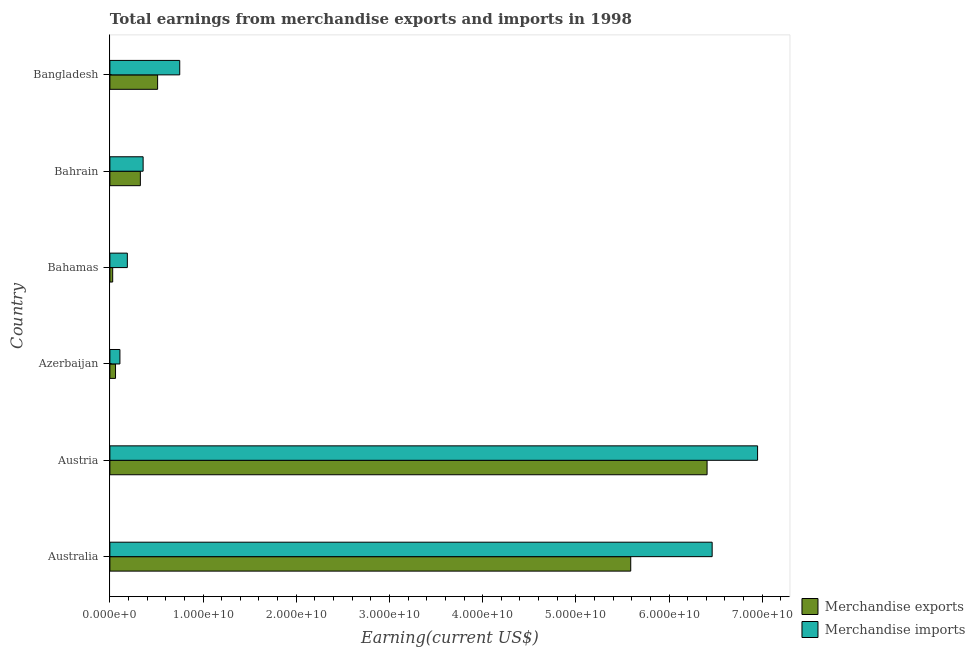How many different coloured bars are there?
Offer a terse response. 2. How many groups of bars are there?
Ensure brevity in your answer.  6. Are the number of bars per tick equal to the number of legend labels?
Make the answer very short. Yes. What is the label of the 6th group of bars from the top?
Your answer should be compact. Australia. In how many cases, is the number of bars for a given country not equal to the number of legend labels?
Provide a short and direct response. 0. What is the earnings from merchandise exports in Australia?
Make the answer very short. 5.59e+1. Across all countries, what is the maximum earnings from merchandise imports?
Provide a succinct answer. 6.95e+1. Across all countries, what is the minimum earnings from merchandise imports?
Provide a short and direct response. 1.08e+09. In which country was the earnings from merchandise exports minimum?
Give a very brief answer. Bahamas. What is the total earnings from merchandise exports in the graph?
Offer a terse response. 1.29e+11. What is the difference between the earnings from merchandise imports in Australia and that in Bangladesh?
Offer a terse response. 5.71e+1. What is the difference between the earnings from merchandise exports in Austria and the earnings from merchandise imports in Bahamas?
Your response must be concise. 6.22e+1. What is the average earnings from merchandise exports per country?
Give a very brief answer. 2.15e+1. What is the difference between the earnings from merchandise exports and earnings from merchandise imports in Austria?
Keep it short and to the point. -5.42e+09. What is the ratio of the earnings from merchandise exports in Australia to that in Azerbaijan?
Provide a succinct answer. 92.39. Is the earnings from merchandise imports in Australia less than that in Azerbaijan?
Your response must be concise. No. Is the difference between the earnings from merchandise imports in Australia and Bangladesh greater than the difference between the earnings from merchandise exports in Australia and Bangladesh?
Your answer should be compact. Yes. What is the difference between the highest and the second highest earnings from merchandise exports?
Provide a short and direct response. 8.19e+09. What is the difference between the highest and the lowest earnings from merchandise exports?
Give a very brief answer. 6.38e+1. In how many countries, is the earnings from merchandise imports greater than the average earnings from merchandise imports taken over all countries?
Your response must be concise. 2. Are all the bars in the graph horizontal?
Offer a very short reply. Yes. What is the difference between two consecutive major ticks on the X-axis?
Provide a short and direct response. 1.00e+1. Are the values on the major ticks of X-axis written in scientific E-notation?
Keep it short and to the point. Yes. Where does the legend appear in the graph?
Your response must be concise. Bottom right. How many legend labels are there?
Offer a terse response. 2. How are the legend labels stacked?
Keep it short and to the point. Vertical. What is the title of the graph?
Your answer should be compact. Total earnings from merchandise exports and imports in 1998. Does "Domestic Liabilities" appear as one of the legend labels in the graph?
Offer a very short reply. No. What is the label or title of the X-axis?
Give a very brief answer. Earning(current US$). What is the Earning(current US$) in Merchandise exports in Australia?
Ensure brevity in your answer.  5.59e+1. What is the Earning(current US$) in Merchandise imports in Australia?
Ensure brevity in your answer.  6.46e+1. What is the Earning(current US$) of Merchandise exports in Austria?
Give a very brief answer. 6.41e+1. What is the Earning(current US$) in Merchandise imports in Austria?
Offer a very short reply. 6.95e+1. What is the Earning(current US$) of Merchandise exports in Azerbaijan?
Your answer should be very brief. 6.05e+08. What is the Earning(current US$) of Merchandise imports in Azerbaijan?
Keep it short and to the point. 1.08e+09. What is the Earning(current US$) in Merchandise exports in Bahamas?
Offer a very short reply. 3.00e+08. What is the Earning(current US$) of Merchandise imports in Bahamas?
Keep it short and to the point. 1.87e+09. What is the Earning(current US$) of Merchandise exports in Bahrain?
Provide a short and direct response. 3.27e+09. What is the Earning(current US$) in Merchandise imports in Bahrain?
Make the answer very short. 3.57e+09. What is the Earning(current US$) of Merchandise exports in Bangladesh?
Your answer should be very brief. 5.12e+09. What is the Earning(current US$) in Merchandise imports in Bangladesh?
Keep it short and to the point. 7.50e+09. Across all countries, what is the maximum Earning(current US$) of Merchandise exports?
Give a very brief answer. 6.41e+1. Across all countries, what is the maximum Earning(current US$) in Merchandise imports?
Your answer should be compact. 6.95e+1. Across all countries, what is the minimum Earning(current US$) of Merchandise exports?
Your answer should be very brief. 3.00e+08. Across all countries, what is the minimum Earning(current US$) of Merchandise imports?
Offer a very short reply. 1.08e+09. What is the total Earning(current US$) in Merchandise exports in the graph?
Make the answer very short. 1.29e+11. What is the total Earning(current US$) in Merchandise imports in the graph?
Provide a short and direct response. 1.48e+11. What is the difference between the Earning(current US$) of Merchandise exports in Australia and that in Austria?
Your answer should be very brief. -8.19e+09. What is the difference between the Earning(current US$) of Merchandise imports in Australia and that in Austria?
Give a very brief answer. -4.87e+09. What is the difference between the Earning(current US$) of Merchandise exports in Australia and that in Azerbaijan?
Make the answer very short. 5.53e+1. What is the difference between the Earning(current US$) of Merchandise imports in Australia and that in Azerbaijan?
Offer a very short reply. 6.36e+1. What is the difference between the Earning(current US$) of Merchandise exports in Australia and that in Bahamas?
Keep it short and to the point. 5.56e+1. What is the difference between the Earning(current US$) in Merchandise imports in Australia and that in Bahamas?
Provide a short and direct response. 6.28e+1. What is the difference between the Earning(current US$) of Merchandise exports in Australia and that in Bahrain?
Give a very brief answer. 5.26e+1. What is the difference between the Earning(current US$) in Merchandise imports in Australia and that in Bahrain?
Your answer should be compact. 6.11e+1. What is the difference between the Earning(current US$) of Merchandise exports in Australia and that in Bangladesh?
Your answer should be very brief. 5.08e+1. What is the difference between the Earning(current US$) in Merchandise imports in Australia and that in Bangladesh?
Offer a terse response. 5.71e+1. What is the difference between the Earning(current US$) of Merchandise exports in Austria and that in Azerbaijan?
Provide a short and direct response. 6.35e+1. What is the difference between the Earning(current US$) of Merchandise imports in Austria and that in Azerbaijan?
Make the answer very short. 6.84e+1. What is the difference between the Earning(current US$) in Merchandise exports in Austria and that in Bahamas?
Provide a succinct answer. 6.38e+1. What is the difference between the Earning(current US$) of Merchandise imports in Austria and that in Bahamas?
Provide a short and direct response. 6.76e+1. What is the difference between the Earning(current US$) in Merchandise exports in Austria and that in Bahrain?
Your response must be concise. 6.08e+1. What is the difference between the Earning(current US$) of Merchandise imports in Austria and that in Bahrain?
Give a very brief answer. 6.59e+1. What is the difference between the Earning(current US$) of Merchandise exports in Austria and that in Bangladesh?
Make the answer very short. 5.90e+1. What is the difference between the Earning(current US$) in Merchandise imports in Austria and that in Bangladesh?
Offer a very short reply. 6.20e+1. What is the difference between the Earning(current US$) of Merchandise exports in Azerbaijan and that in Bahamas?
Provide a succinct answer. 3.05e+08. What is the difference between the Earning(current US$) of Merchandise imports in Azerbaijan and that in Bahamas?
Provide a short and direct response. -7.97e+08. What is the difference between the Earning(current US$) in Merchandise exports in Azerbaijan and that in Bahrain?
Your answer should be very brief. -2.66e+09. What is the difference between the Earning(current US$) in Merchandise imports in Azerbaijan and that in Bahrain?
Give a very brief answer. -2.49e+09. What is the difference between the Earning(current US$) in Merchandise exports in Azerbaijan and that in Bangladesh?
Provide a short and direct response. -4.52e+09. What is the difference between the Earning(current US$) in Merchandise imports in Azerbaijan and that in Bangladesh?
Give a very brief answer. -6.42e+09. What is the difference between the Earning(current US$) of Merchandise exports in Bahamas and that in Bahrain?
Your answer should be compact. -2.97e+09. What is the difference between the Earning(current US$) in Merchandise imports in Bahamas and that in Bahrain?
Offer a terse response. -1.69e+09. What is the difference between the Earning(current US$) in Merchandise exports in Bahamas and that in Bangladesh?
Ensure brevity in your answer.  -4.82e+09. What is the difference between the Earning(current US$) in Merchandise imports in Bahamas and that in Bangladesh?
Offer a very short reply. -5.62e+09. What is the difference between the Earning(current US$) of Merchandise exports in Bahrain and that in Bangladesh?
Offer a very short reply. -1.85e+09. What is the difference between the Earning(current US$) in Merchandise imports in Bahrain and that in Bangladesh?
Ensure brevity in your answer.  -3.93e+09. What is the difference between the Earning(current US$) in Merchandise exports in Australia and the Earning(current US$) in Merchandise imports in Austria?
Give a very brief answer. -1.36e+1. What is the difference between the Earning(current US$) in Merchandise exports in Australia and the Earning(current US$) in Merchandise imports in Azerbaijan?
Keep it short and to the point. 5.48e+1. What is the difference between the Earning(current US$) in Merchandise exports in Australia and the Earning(current US$) in Merchandise imports in Bahamas?
Your answer should be compact. 5.40e+1. What is the difference between the Earning(current US$) in Merchandise exports in Australia and the Earning(current US$) in Merchandise imports in Bahrain?
Provide a succinct answer. 5.23e+1. What is the difference between the Earning(current US$) of Merchandise exports in Australia and the Earning(current US$) of Merchandise imports in Bangladesh?
Offer a very short reply. 4.84e+1. What is the difference between the Earning(current US$) in Merchandise exports in Austria and the Earning(current US$) in Merchandise imports in Azerbaijan?
Give a very brief answer. 6.30e+1. What is the difference between the Earning(current US$) of Merchandise exports in Austria and the Earning(current US$) of Merchandise imports in Bahamas?
Give a very brief answer. 6.22e+1. What is the difference between the Earning(current US$) in Merchandise exports in Austria and the Earning(current US$) in Merchandise imports in Bahrain?
Your response must be concise. 6.05e+1. What is the difference between the Earning(current US$) of Merchandise exports in Austria and the Earning(current US$) of Merchandise imports in Bangladesh?
Keep it short and to the point. 5.66e+1. What is the difference between the Earning(current US$) of Merchandise exports in Azerbaijan and the Earning(current US$) of Merchandise imports in Bahamas?
Offer a terse response. -1.27e+09. What is the difference between the Earning(current US$) of Merchandise exports in Azerbaijan and the Earning(current US$) of Merchandise imports in Bahrain?
Your response must be concise. -2.96e+09. What is the difference between the Earning(current US$) of Merchandise exports in Azerbaijan and the Earning(current US$) of Merchandise imports in Bangladesh?
Your answer should be compact. -6.89e+09. What is the difference between the Earning(current US$) in Merchandise exports in Bahamas and the Earning(current US$) in Merchandise imports in Bahrain?
Give a very brief answer. -3.27e+09. What is the difference between the Earning(current US$) in Merchandise exports in Bahamas and the Earning(current US$) in Merchandise imports in Bangladesh?
Offer a very short reply. -7.20e+09. What is the difference between the Earning(current US$) of Merchandise exports in Bahrain and the Earning(current US$) of Merchandise imports in Bangladesh?
Your response must be concise. -4.22e+09. What is the average Earning(current US$) in Merchandise exports per country?
Give a very brief answer. 2.15e+1. What is the average Earning(current US$) of Merchandise imports per country?
Offer a very short reply. 2.47e+1. What is the difference between the Earning(current US$) in Merchandise exports and Earning(current US$) in Merchandise imports in Australia?
Keep it short and to the point. -8.74e+09. What is the difference between the Earning(current US$) in Merchandise exports and Earning(current US$) in Merchandise imports in Austria?
Offer a terse response. -5.42e+09. What is the difference between the Earning(current US$) of Merchandise exports and Earning(current US$) of Merchandise imports in Azerbaijan?
Provide a short and direct response. -4.71e+08. What is the difference between the Earning(current US$) of Merchandise exports and Earning(current US$) of Merchandise imports in Bahamas?
Provide a succinct answer. -1.57e+09. What is the difference between the Earning(current US$) in Merchandise exports and Earning(current US$) in Merchandise imports in Bahrain?
Your response must be concise. -2.96e+08. What is the difference between the Earning(current US$) in Merchandise exports and Earning(current US$) in Merchandise imports in Bangladesh?
Keep it short and to the point. -2.37e+09. What is the ratio of the Earning(current US$) in Merchandise exports in Australia to that in Austria?
Your response must be concise. 0.87. What is the ratio of the Earning(current US$) of Merchandise imports in Australia to that in Austria?
Provide a short and direct response. 0.93. What is the ratio of the Earning(current US$) of Merchandise exports in Australia to that in Azerbaijan?
Ensure brevity in your answer.  92.39. What is the ratio of the Earning(current US$) of Merchandise imports in Australia to that in Azerbaijan?
Your answer should be compact. 60.07. What is the ratio of the Earning(current US$) of Merchandise exports in Australia to that in Bahamas?
Your response must be concise. 186.31. What is the ratio of the Earning(current US$) of Merchandise imports in Australia to that in Bahamas?
Offer a terse response. 34.51. What is the ratio of the Earning(current US$) in Merchandise exports in Australia to that in Bahrain?
Provide a short and direct response. 17.09. What is the ratio of the Earning(current US$) in Merchandise imports in Australia to that in Bahrain?
Keep it short and to the point. 18.12. What is the ratio of the Earning(current US$) of Merchandise exports in Australia to that in Bangladesh?
Make the answer very short. 10.91. What is the ratio of the Earning(current US$) in Merchandise imports in Australia to that in Bangladesh?
Your response must be concise. 8.62. What is the ratio of the Earning(current US$) in Merchandise exports in Austria to that in Azerbaijan?
Provide a short and direct response. 105.93. What is the ratio of the Earning(current US$) in Merchandise imports in Austria to that in Azerbaijan?
Provide a succinct answer. 64.6. What is the ratio of the Earning(current US$) of Merchandise exports in Austria to that in Bahamas?
Keep it short and to the point. 213.62. What is the ratio of the Earning(current US$) in Merchandise imports in Austria to that in Bahamas?
Your answer should be very brief. 37.11. What is the ratio of the Earning(current US$) of Merchandise exports in Austria to that in Bahrain?
Your answer should be compact. 19.6. What is the ratio of the Earning(current US$) of Merchandise imports in Austria to that in Bahrain?
Ensure brevity in your answer.  19.49. What is the ratio of the Earning(current US$) in Merchandise exports in Austria to that in Bangladesh?
Offer a very short reply. 12.51. What is the ratio of the Earning(current US$) in Merchandise imports in Austria to that in Bangladesh?
Your answer should be compact. 9.27. What is the ratio of the Earning(current US$) in Merchandise exports in Azerbaijan to that in Bahamas?
Make the answer very short. 2.02. What is the ratio of the Earning(current US$) of Merchandise imports in Azerbaijan to that in Bahamas?
Offer a terse response. 0.57. What is the ratio of the Earning(current US$) in Merchandise exports in Azerbaijan to that in Bahrain?
Your response must be concise. 0.18. What is the ratio of the Earning(current US$) in Merchandise imports in Azerbaijan to that in Bahrain?
Offer a very short reply. 0.3. What is the ratio of the Earning(current US$) of Merchandise exports in Azerbaijan to that in Bangladesh?
Offer a very short reply. 0.12. What is the ratio of the Earning(current US$) of Merchandise imports in Azerbaijan to that in Bangladesh?
Offer a very short reply. 0.14. What is the ratio of the Earning(current US$) of Merchandise exports in Bahamas to that in Bahrain?
Provide a short and direct response. 0.09. What is the ratio of the Earning(current US$) in Merchandise imports in Bahamas to that in Bahrain?
Offer a terse response. 0.53. What is the ratio of the Earning(current US$) of Merchandise exports in Bahamas to that in Bangladesh?
Your answer should be very brief. 0.06. What is the ratio of the Earning(current US$) in Merchandise imports in Bahamas to that in Bangladesh?
Give a very brief answer. 0.25. What is the ratio of the Earning(current US$) in Merchandise exports in Bahrain to that in Bangladesh?
Your answer should be very brief. 0.64. What is the ratio of the Earning(current US$) in Merchandise imports in Bahrain to that in Bangladesh?
Offer a very short reply. 0.48. What is the difference between the highest and the second highest Earning(current US$) in Merchandise exports?
Ensure brevity in your answer.  8.19e+09. What is the difference between the highest and the second highest Earning(current US$) of Merchandise imports?
Keep it short and to the point. 4.87e+09. What is the difference between the highest and the lowest Earning(current US$) of Merchandise exports?
Make the answer very short. 6.38e+1. What is the difference between the highest and the lowest Earning(current US$) in Merchandise imports?
Your answer should be compact. 6.84e+1. 